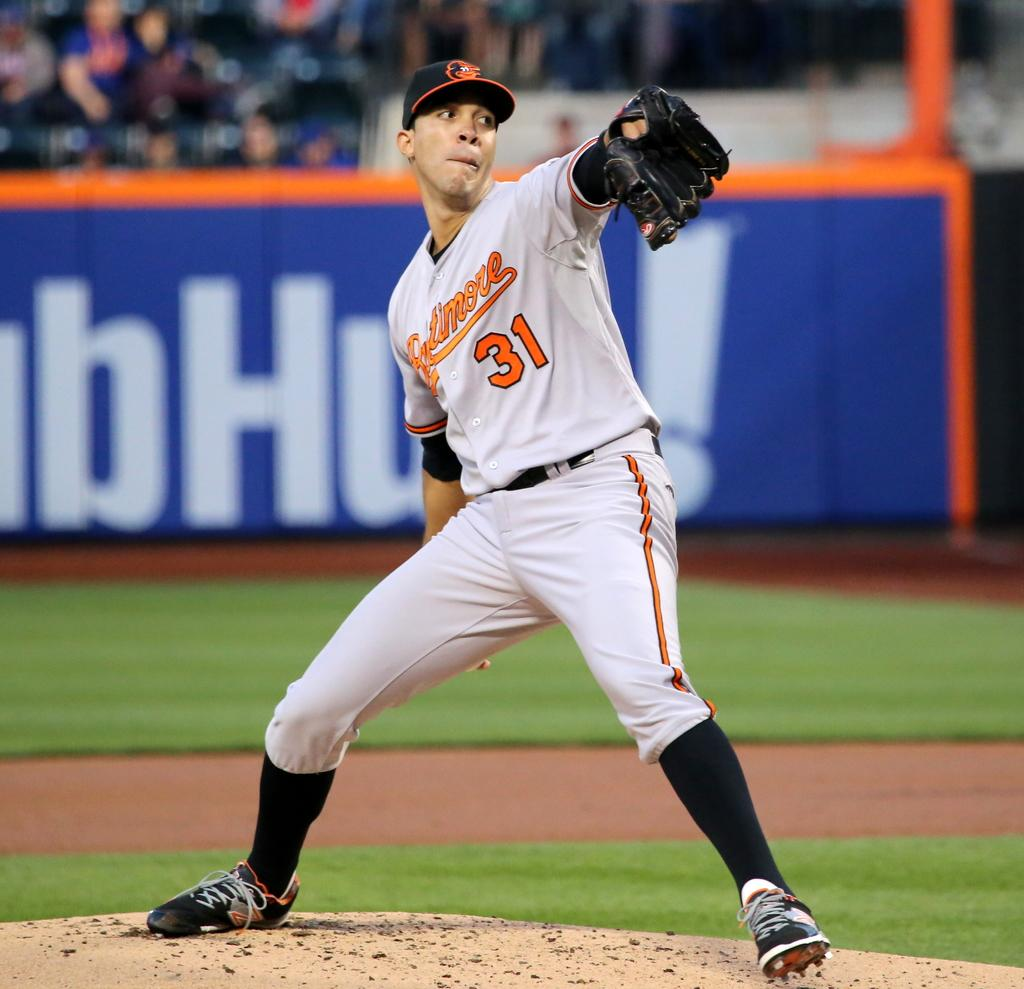<image>
Share a concise interpretation of the image provided. Baltimore pitcher #31 prepares to throw a pitch. 